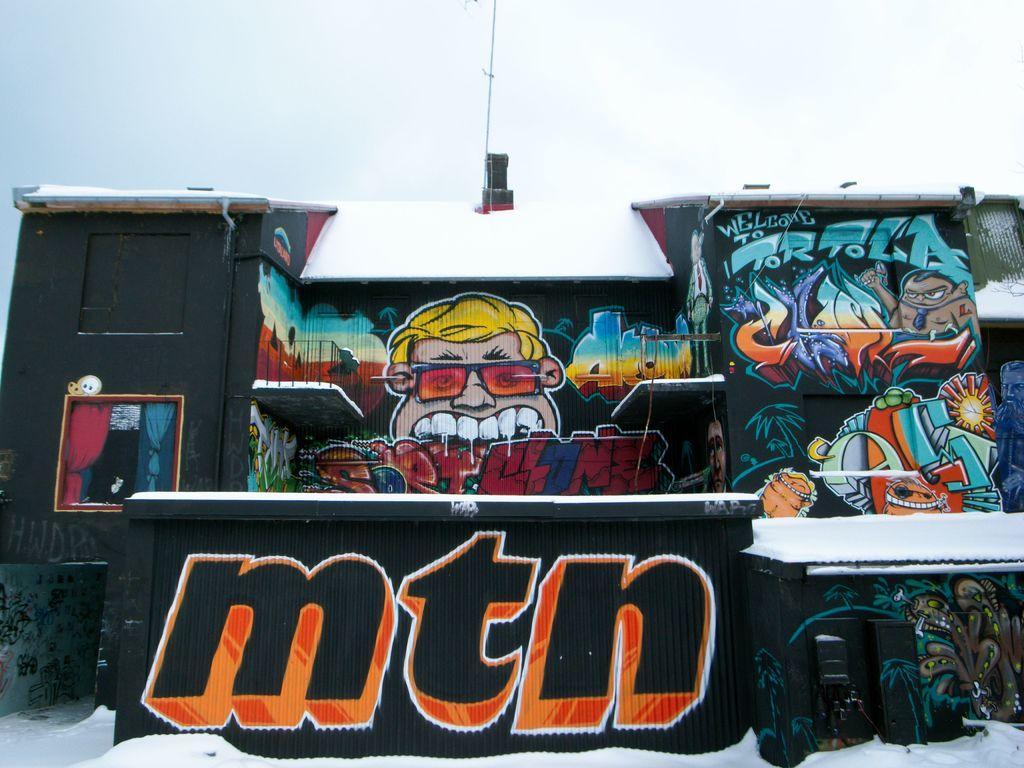Can you describe this image briefly? This picture seems to be clicked outside. In the foreground we can see the snow. In the center we can see the the building and we can see the text on a black color shutter and we can see the curtains, window and we can see the art of graffiti on the building which includes the pictures of persons and the pictures of some other objects. In the background we can see the sky and some other objects. 